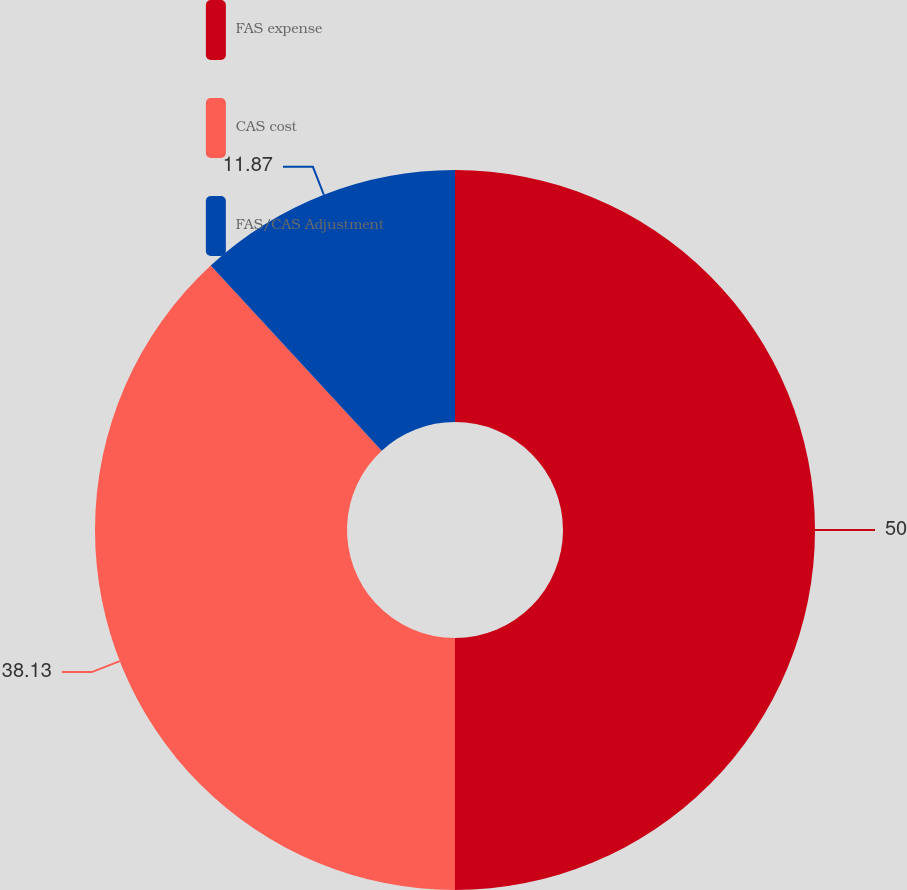Convert chart. <chart><loc_0><loc_0><loc_500><loc_500><pie_chart><fcel>FAS expense<fcel>CAS cost<fcel>FAS/CAS Adjustment<nl><fcel>50.0%<fcel>38.13%<fcel>11.87%<nl></chart> 